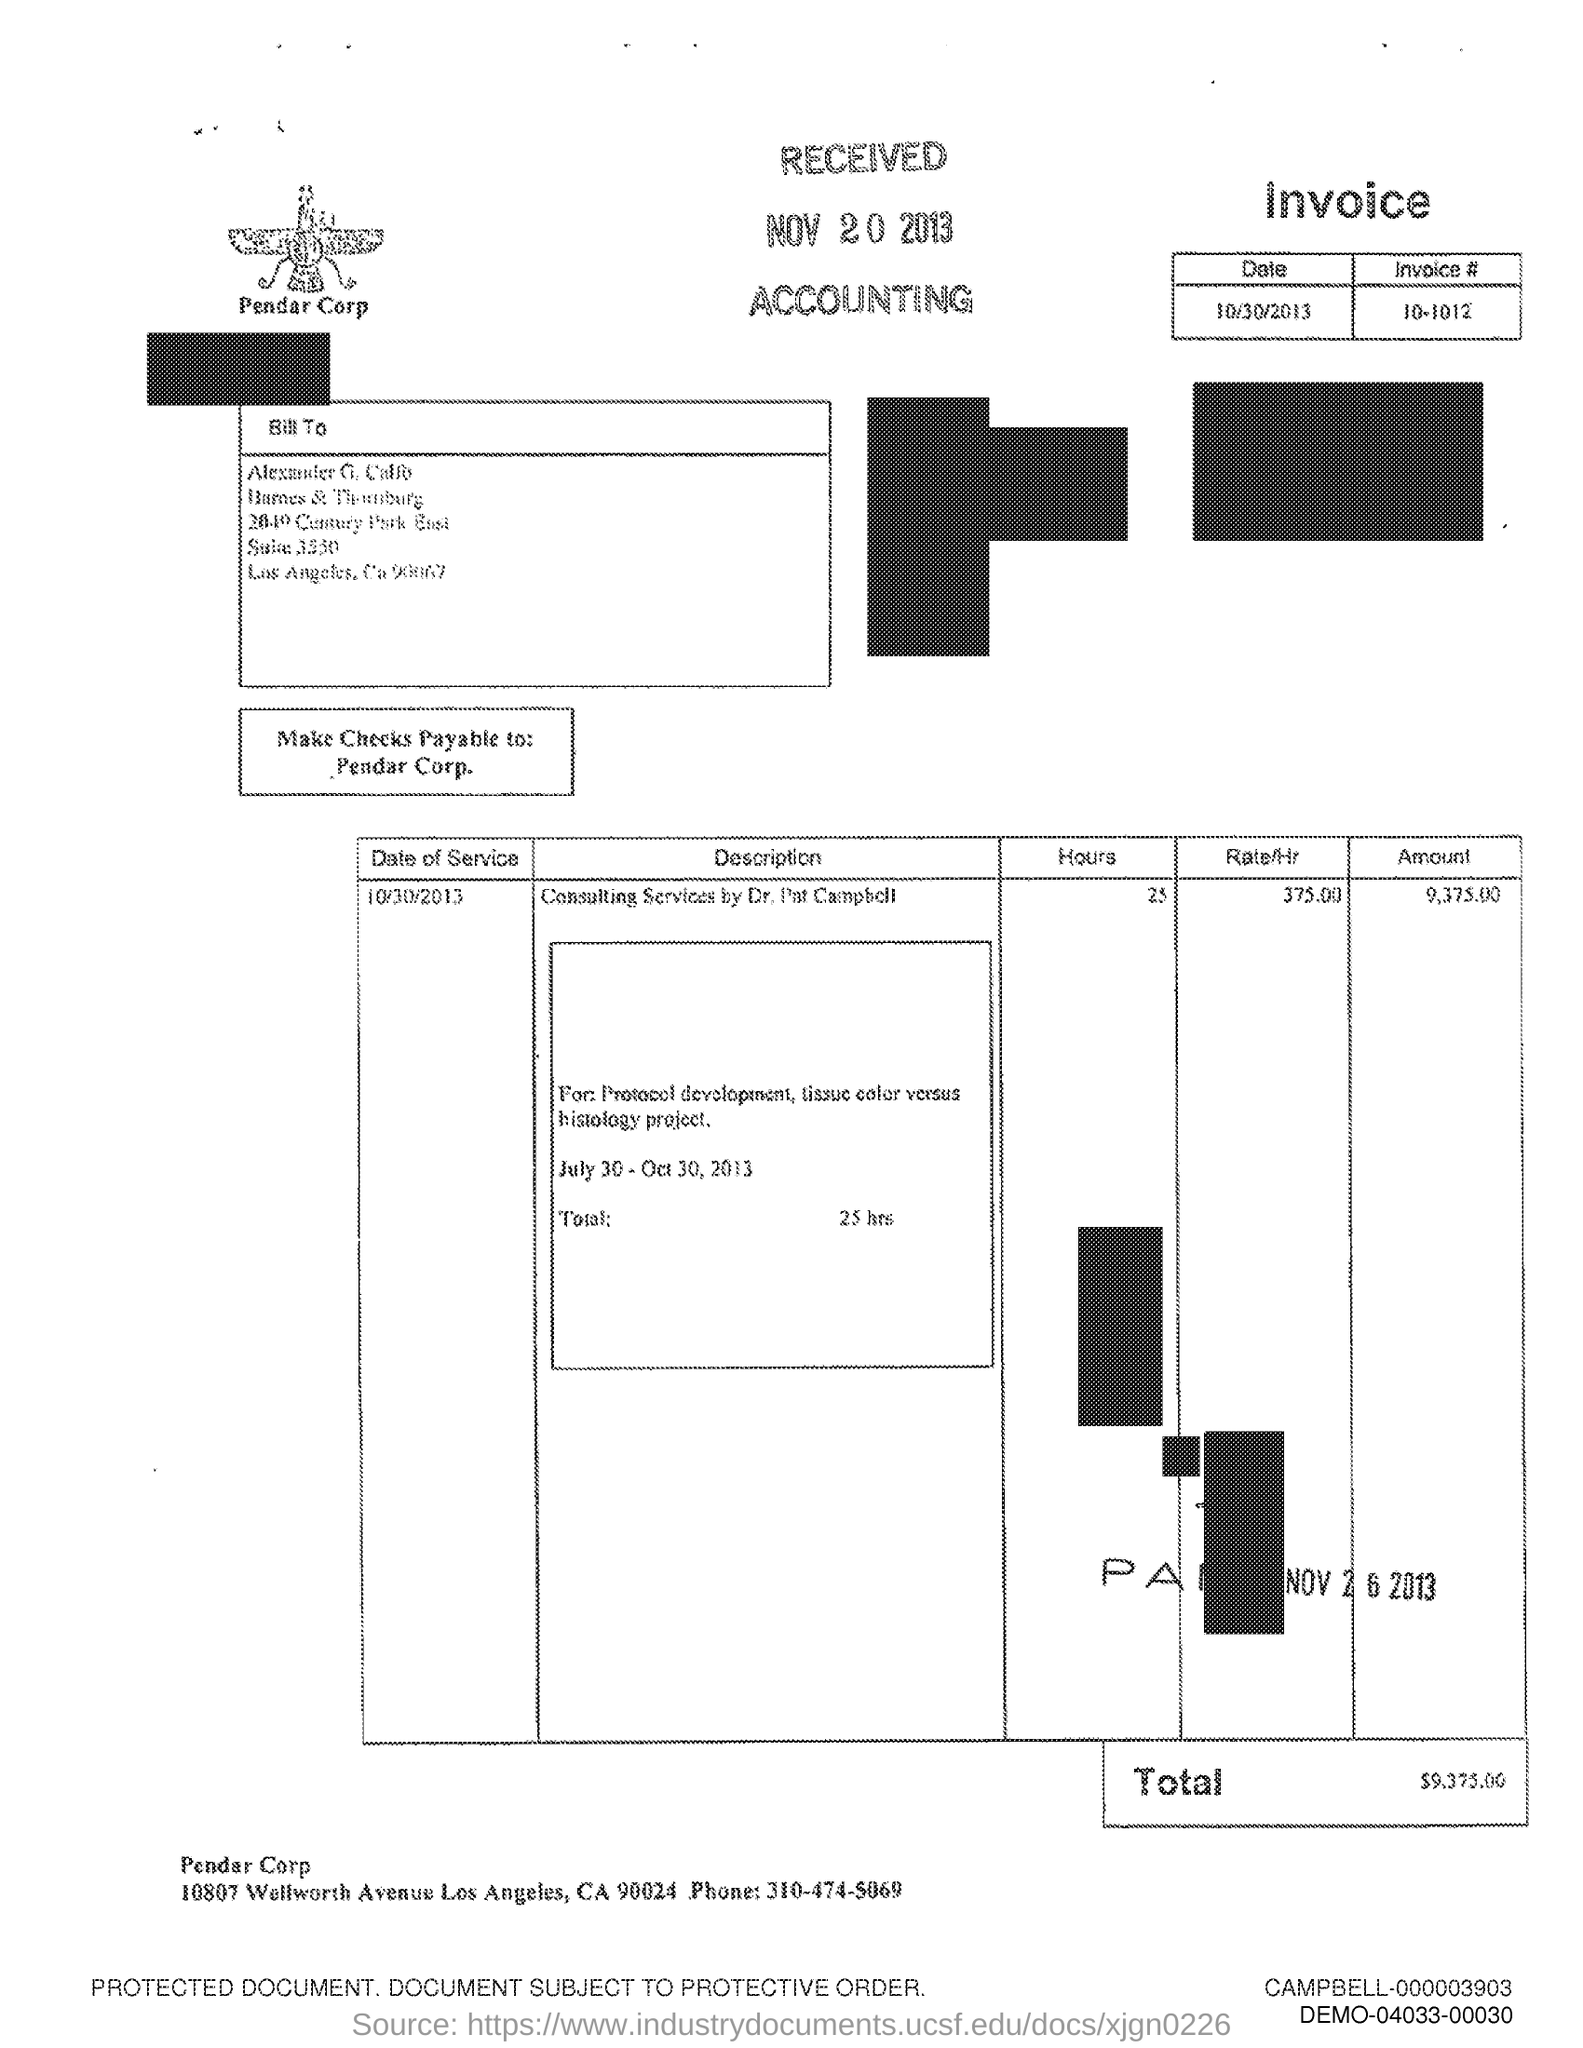Draw attention to some important aspects in this diagram. The text that is written below the image is 'Pendar Corp.'. The phone number mentioned in the document is 310-474-5069. 